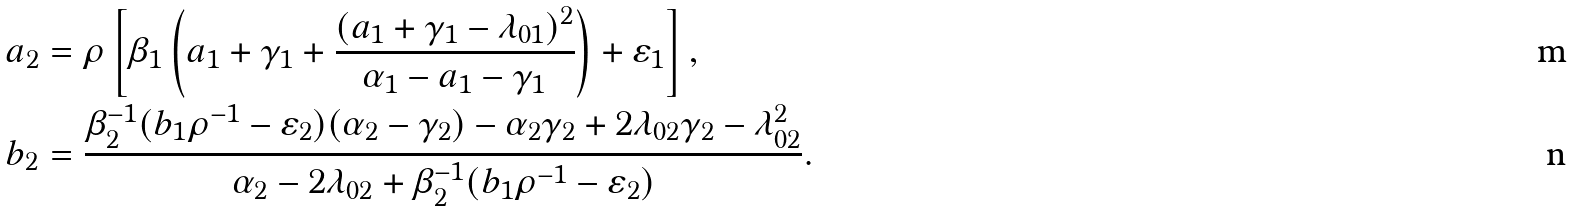<formula> <loc_0><loc_0><loc_500><loc_500>a _ { 2 } & = \rho \left [ \beta _ { 1 } \left ( a _ { 1 } + \gamma _ { 1 } + \frac { ( a _ { 1 } + \gamma _ { 1 } - \lambda _ { 0 1 } ) ^ { 2 } } { \alpha _ { 1 } - a _ { 1 } - \gamma _ { 1 } } \right ) + \varepsilon _ { 1 } \right ] , \\ b _ { 2 } & = \frac { \beta _ { 2 } ^ { - 1 } ( b _ { 1 } \rho ^ { - 1 } - \varepsilon _ { 2 } ) ( \alpha _ { 2 } - \gamma _ { 2 } ) - \alpha _ { 2 } \gamma _ { 2 } + 2 \lambda _ { 0 2 } \gamma _ { 2 } - \lambda ^ { 2 } _ { 0 2 } } { \alpha _ { 2 } - 2 \lambda _ { 0 2 } + \beta _ { 2 } ^ { - 1 } ( b _ { 1 } \rho ^ { - 1 } - \varepsilon _ { 2 } ) } .</formula> 